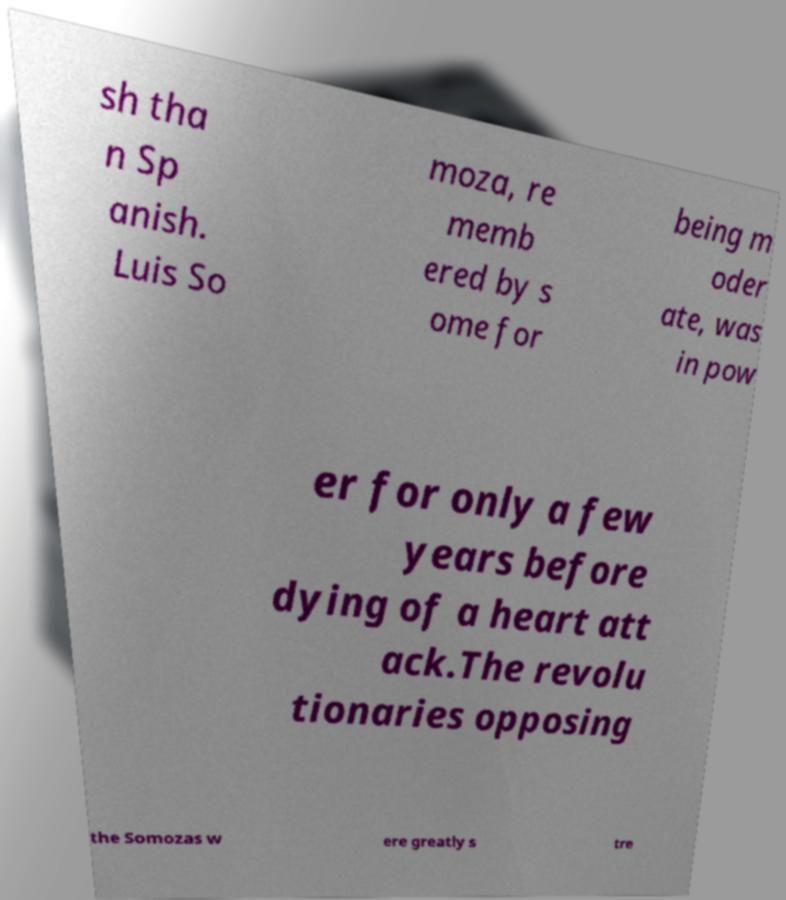Can you read and provide the text displayed in the image?This photo seems to have some interesting text. Can you extract and type it out for me? sh tha n Sp anish. Luis So moza, re memb ered by s ome for being m oder ate, was in pow er for only a few years before dying of a heart att ack.The revolu tionaries opposing the Somozas w ere greatly s tre 